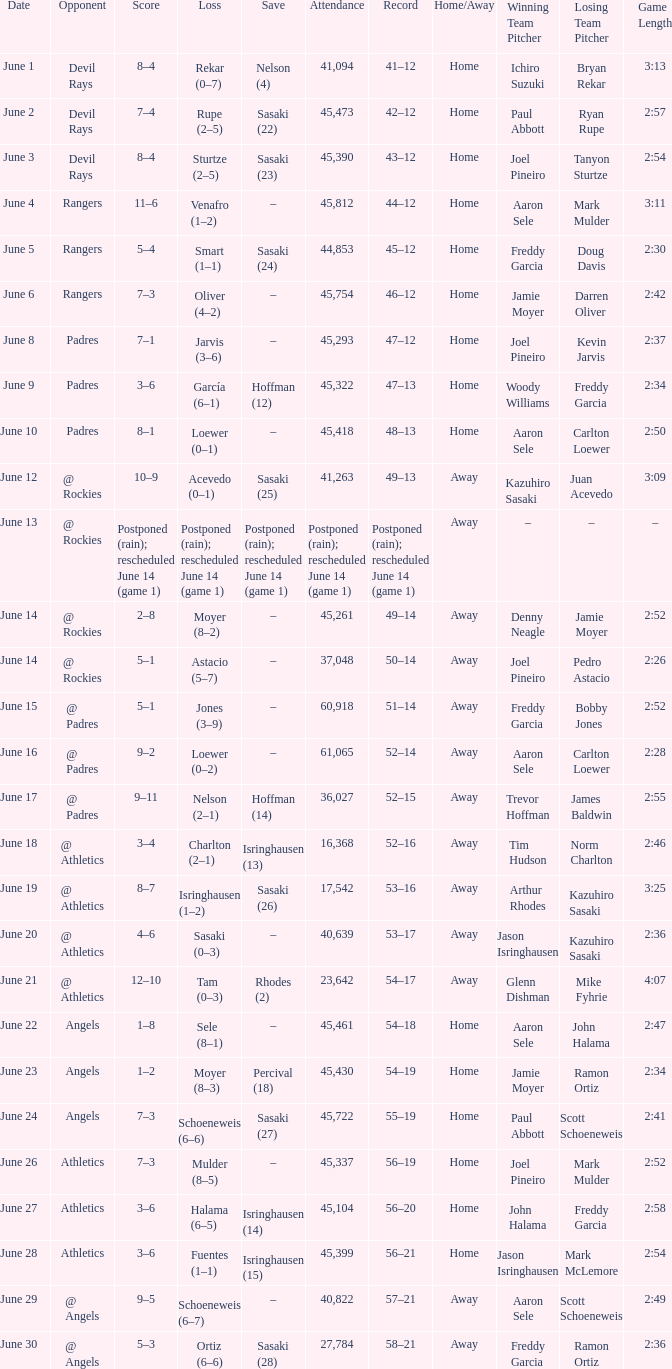What was the score of the Mariners game when they had a record of 56–21? 3–6. 